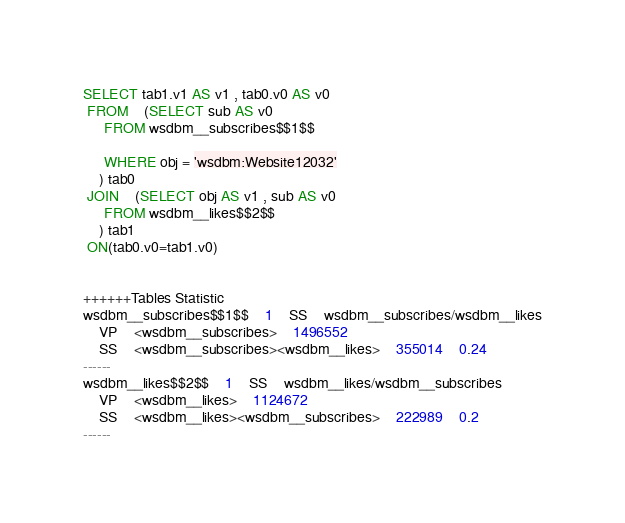Convert code to text. <code><loc_0><loc_0><loc_500><loc_500><_SQL_>SELECT tab1.v1 AS v1 , tab0.v0 AS v0 
 FROM    (SELECT sub AS v0 
	 FROM wsdbm__subscribes$$1$$
	 
	 WHERE obj = 'wsdbm:Website12032'
	) tab0
 JOIN    (SELECT obj AS v1 , sub AS v0 
	 FROM wsdbm__likes$$2$$
	) tab1
 ON(tab0.v0=tab1.v0)


++++++Tables Statistic
wsdbm__subscribes$$1$$	1	SS	wsdbm__subscribes/wsdbm__likes
	VP	<wsdbm__subscribes>	1496552
	SS	<wsdbm__subscribes><wsdbm__likes>	355014	0.24
------
wsdbm__likes$$2$$	1	SS	wsdbm__likes/wsdbm__subscribes
	VP	<wsdbm__likes>	1124672
	SS	<wsdbm__likes><wsdbm__subscribes>	222989	0.2
------
</code> 